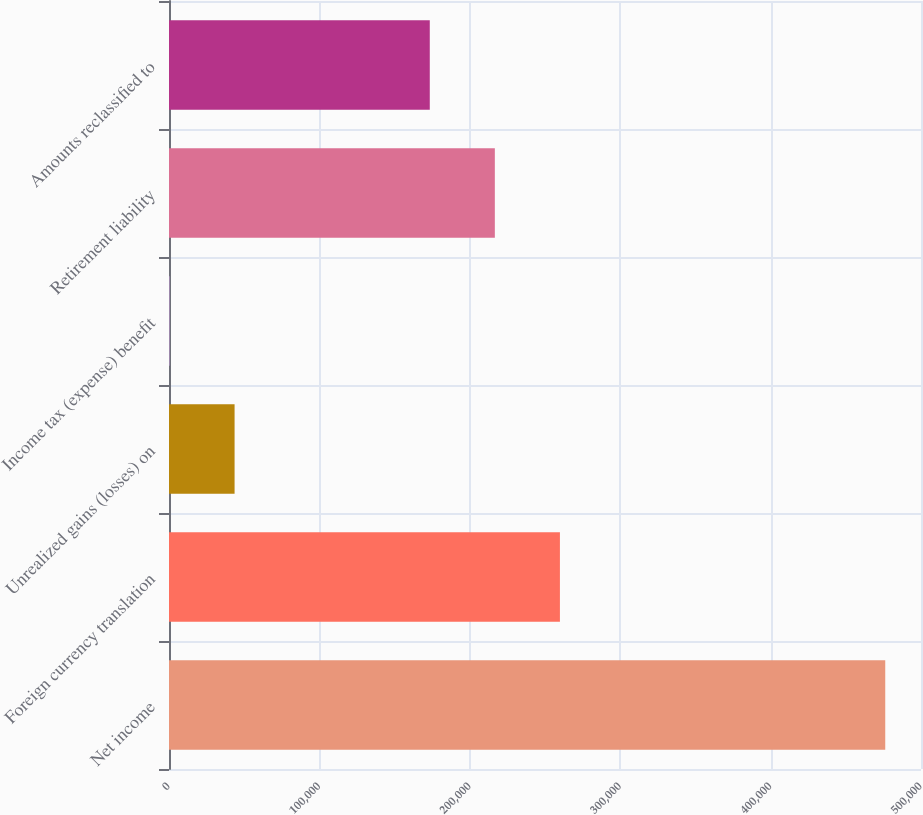<chart> <loc_0><loc_0><loc_500><loc_500><bar_chart><fcel>Net income<fcel>Foreign currency translation<fcel>Unrealized gains (losses) on<fcel>Income tax (expense) benefit<fcel>Retirement liability<fcel>Amounts reclassified to<nl><fcel>476231<fcel>259916<fcel>43601.9<fcel>339<fcel>216654<fcel>173391<nl></chart> 